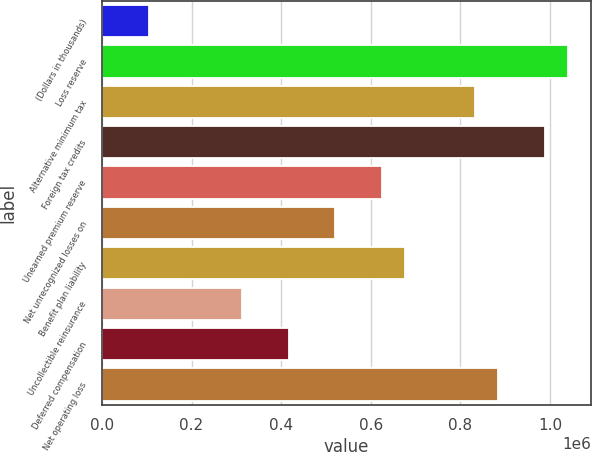Convert chart. <chart><loc_0><loc_0><loc_500><loc_500><bar_chart><fcel>(Dollars in thousands)<fcel>Loss reserve<fcel>Alternative minimum tax<fcel>Foreign tax credits<fcel>Unearned premium reserve<fcel>Net unrecognized losses on<fcel>Benefit plan liability<fcel>Uncollectible reinsurance<fcel>Deferred compensation<fcel>Net operating loss<nl><fcel>105628<fcel>1.04051e+06<fcel>832762<fcel>988576<fcel>625009<fcel>521133<fcel>676947<fcel>313381<fcel>417257<fcel>884700<nl></chart> 